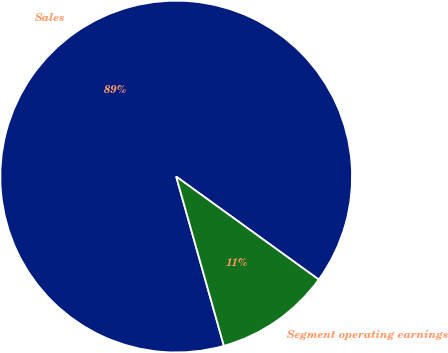Convert chart to OTSL. <chart><loc_0><loc_0><loc_500><loc_500><pie_chart><fcel>Sales<fcel>Segment operating earnings<nl><fcel>89.33%<fcel>10.67%<nl></chart> 